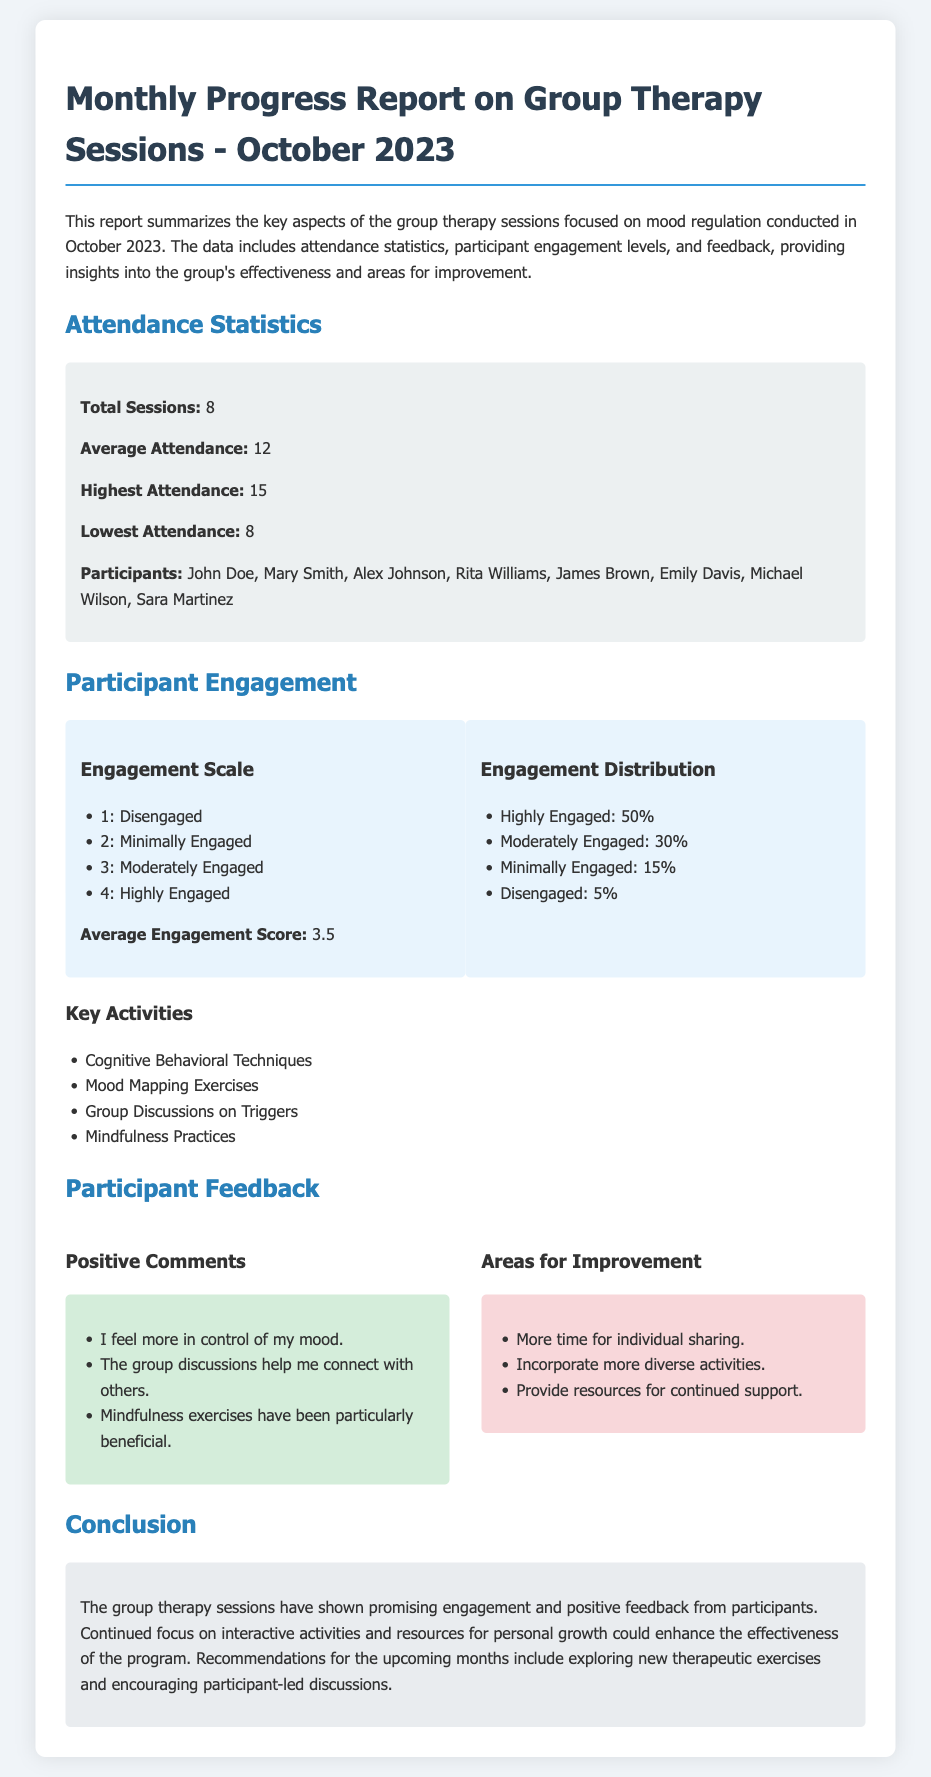What is the total number of sessions? The total number of sessions is stated in the report as 8.
Answer: 8 What is the average attendance? The average attendance is provided as 12 participants per session.
Answer: 12 What percentage of participants were highly engaged? The document mentions that 50% of participants were highly engaged.
Answer: 50% Which techniques were identified as key activities? The report lists Cognitive Behavioral Techniques, Mood Mapping Exercises, Group Discussions on Triggers, and Mindfulness Practices as key activities.
Answer: Cognitive Behavioral Techniques, Mood Mapping Exercises, Group Discussions on Triggers, Mindfulness Practices What was the average engagement score? The average engagement score mentioned in the report is 3.5.
Answer: 3.5 What was a common positive comment received from participants? One positive comment highlighted in the report is about feeling more in control of their mood.
Answer: I feel more in control of my mood What is one area for improvement suggested? The report indicates that incorporating more diverse activities is a suggested area for improvement.
Answer: Incorporate more diverse activities What is the title of the report? The title of the report is stated as "Monthly Progress Report on Group Therapy Sessions - October 2023."
Answer: Monthly Progress Report on Group Therapy Sessions - October 2023 What conclusion is drawn regarding participant engagement? The conclusion indicates that the group therapy sessions have shown promising engagement from participants.
Answer: Promising engagement 